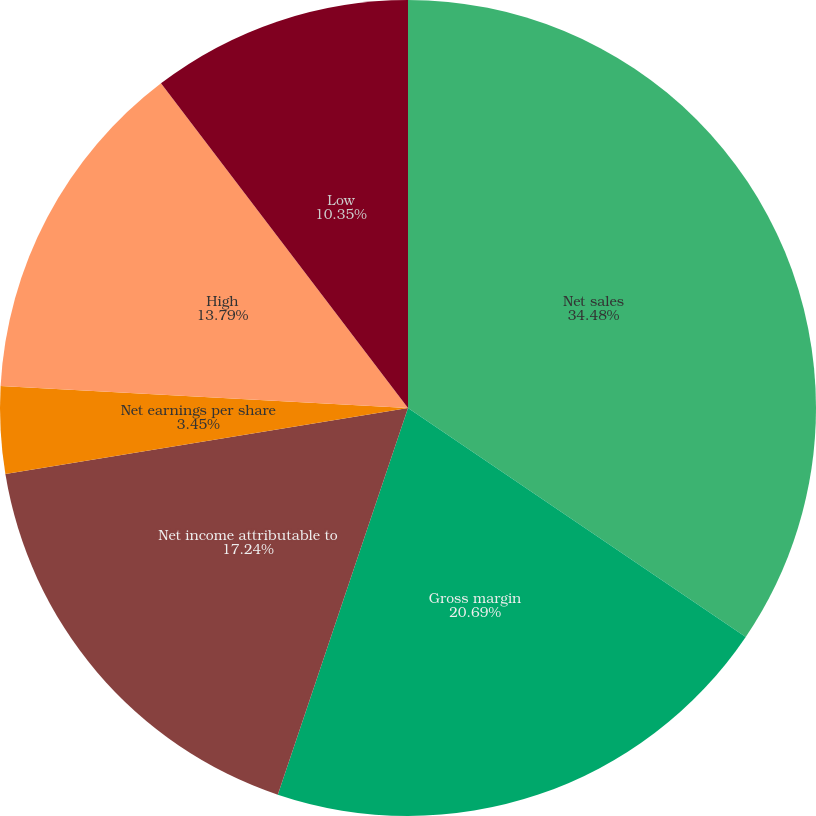<chart> <loc_0><loc_0><loc_500><loc_500><pie_chart><fcel>Net sales<fcel>Gross margin<fcel>Net income attributable to<fcel>Net earnings per share<fcel>Cash dividends per share<fcel>High<fcel>Low<nl><fcel>34.48%<fcel>20.69%<fcel>17.24%<fcel>3.45%<fcel>0.0%<fcel>13.79%<fcel>10.35%<nl></chart> 